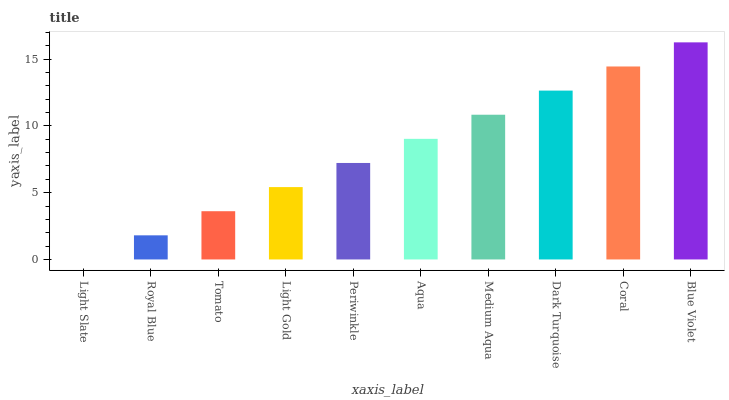Is Royal Blue the minimum?
Answer yes or no. No. Is Royal Blue the maximum?
Answer yes or no. No. Is Royal Blue greater than Light Slate?
Answer yes or no. Yes. Is Light Slate less than Royal Blue?
Answer yes or no. Yes. Is Light Slate greater than Royal Blue?
Answer yes or no. No. Is Royal Blue less than Light Slate?
Answer yes or no. No. Is Aqua the high median?
Answer yes or no. Yes. Is Periwinkle the low median?
Answer yes or no. Yes. Is Coral the high median?
Answer yes or no. No. Is Blue Violet the low median?
Answer yes or no. No. 